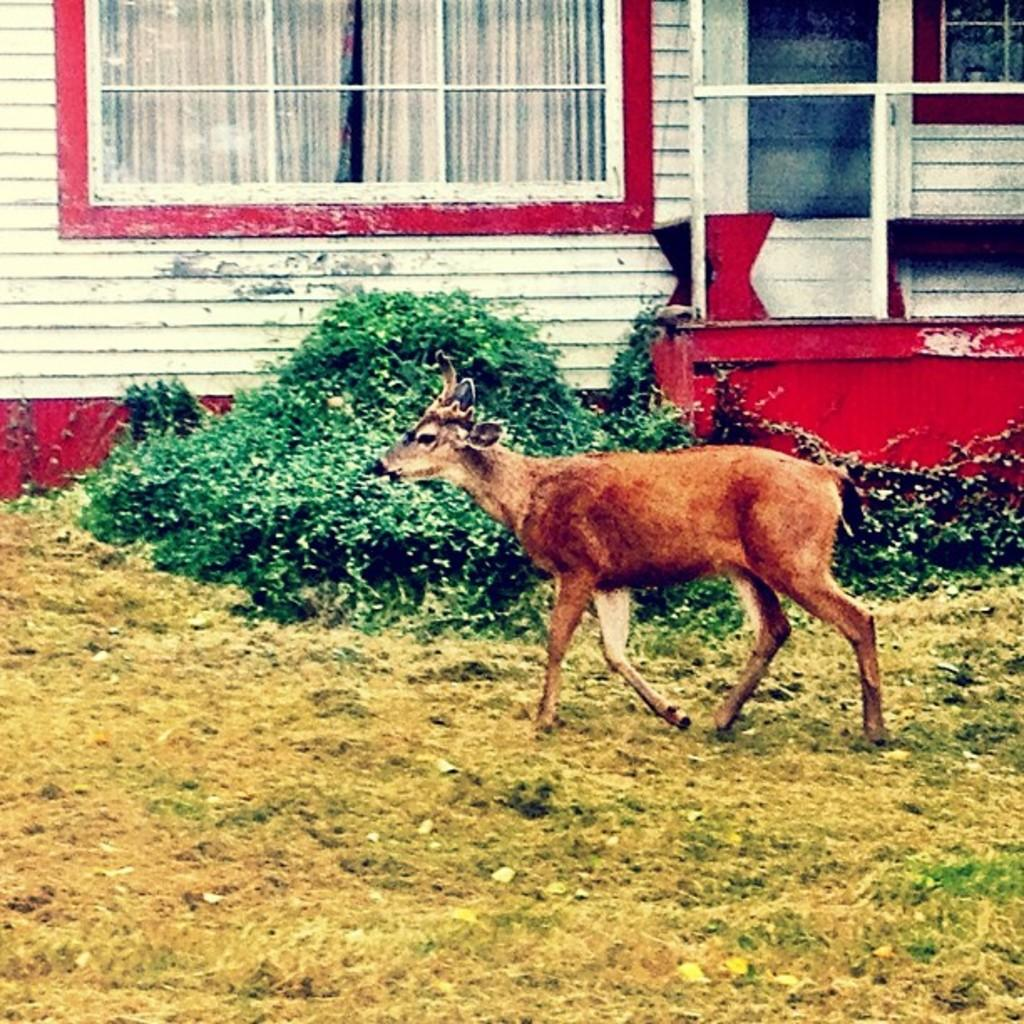What type of animal is in the image? There is an animal in the image, but the specific type cannot be determined from the provided facts. Where is the animal located in the image? The animal is on the grass in the image. What can be seen in the background of the image? In the background of the image, there are plants, windows, curtains, a wall, and some objects. What type of duck is present in the image, and what order does it belong to? There is no duck present in the image, and therefore it cannot be determined what order it would belong to. 